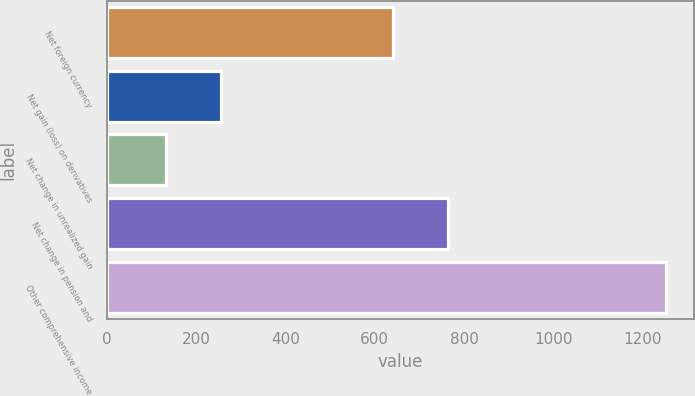<chart> <loc_0><loc_0><loc_500><loc_500><bar_chart><fcel>Net foreign currency<fcel>Net gain (loss) on derivatives<fcel>Net change in unrealized gain<fcel>Net change in pension and<fcel>Other comprehensive income<nl><fcel>640<fcel>256.2<fcel>131.6<fcel>764.6<fcel>1253<nl></chart> 